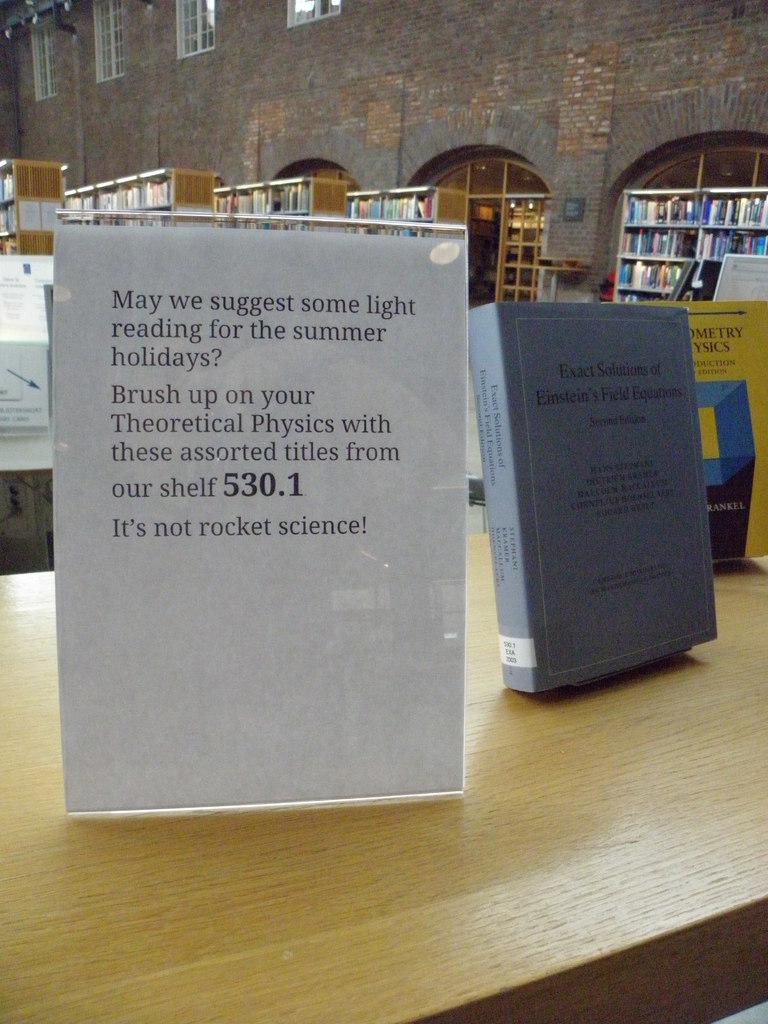What concept this book?
Your response must be concise. Theoretical physics. What season are they suggesting readings for?
Give a very brief answer. Summer. 